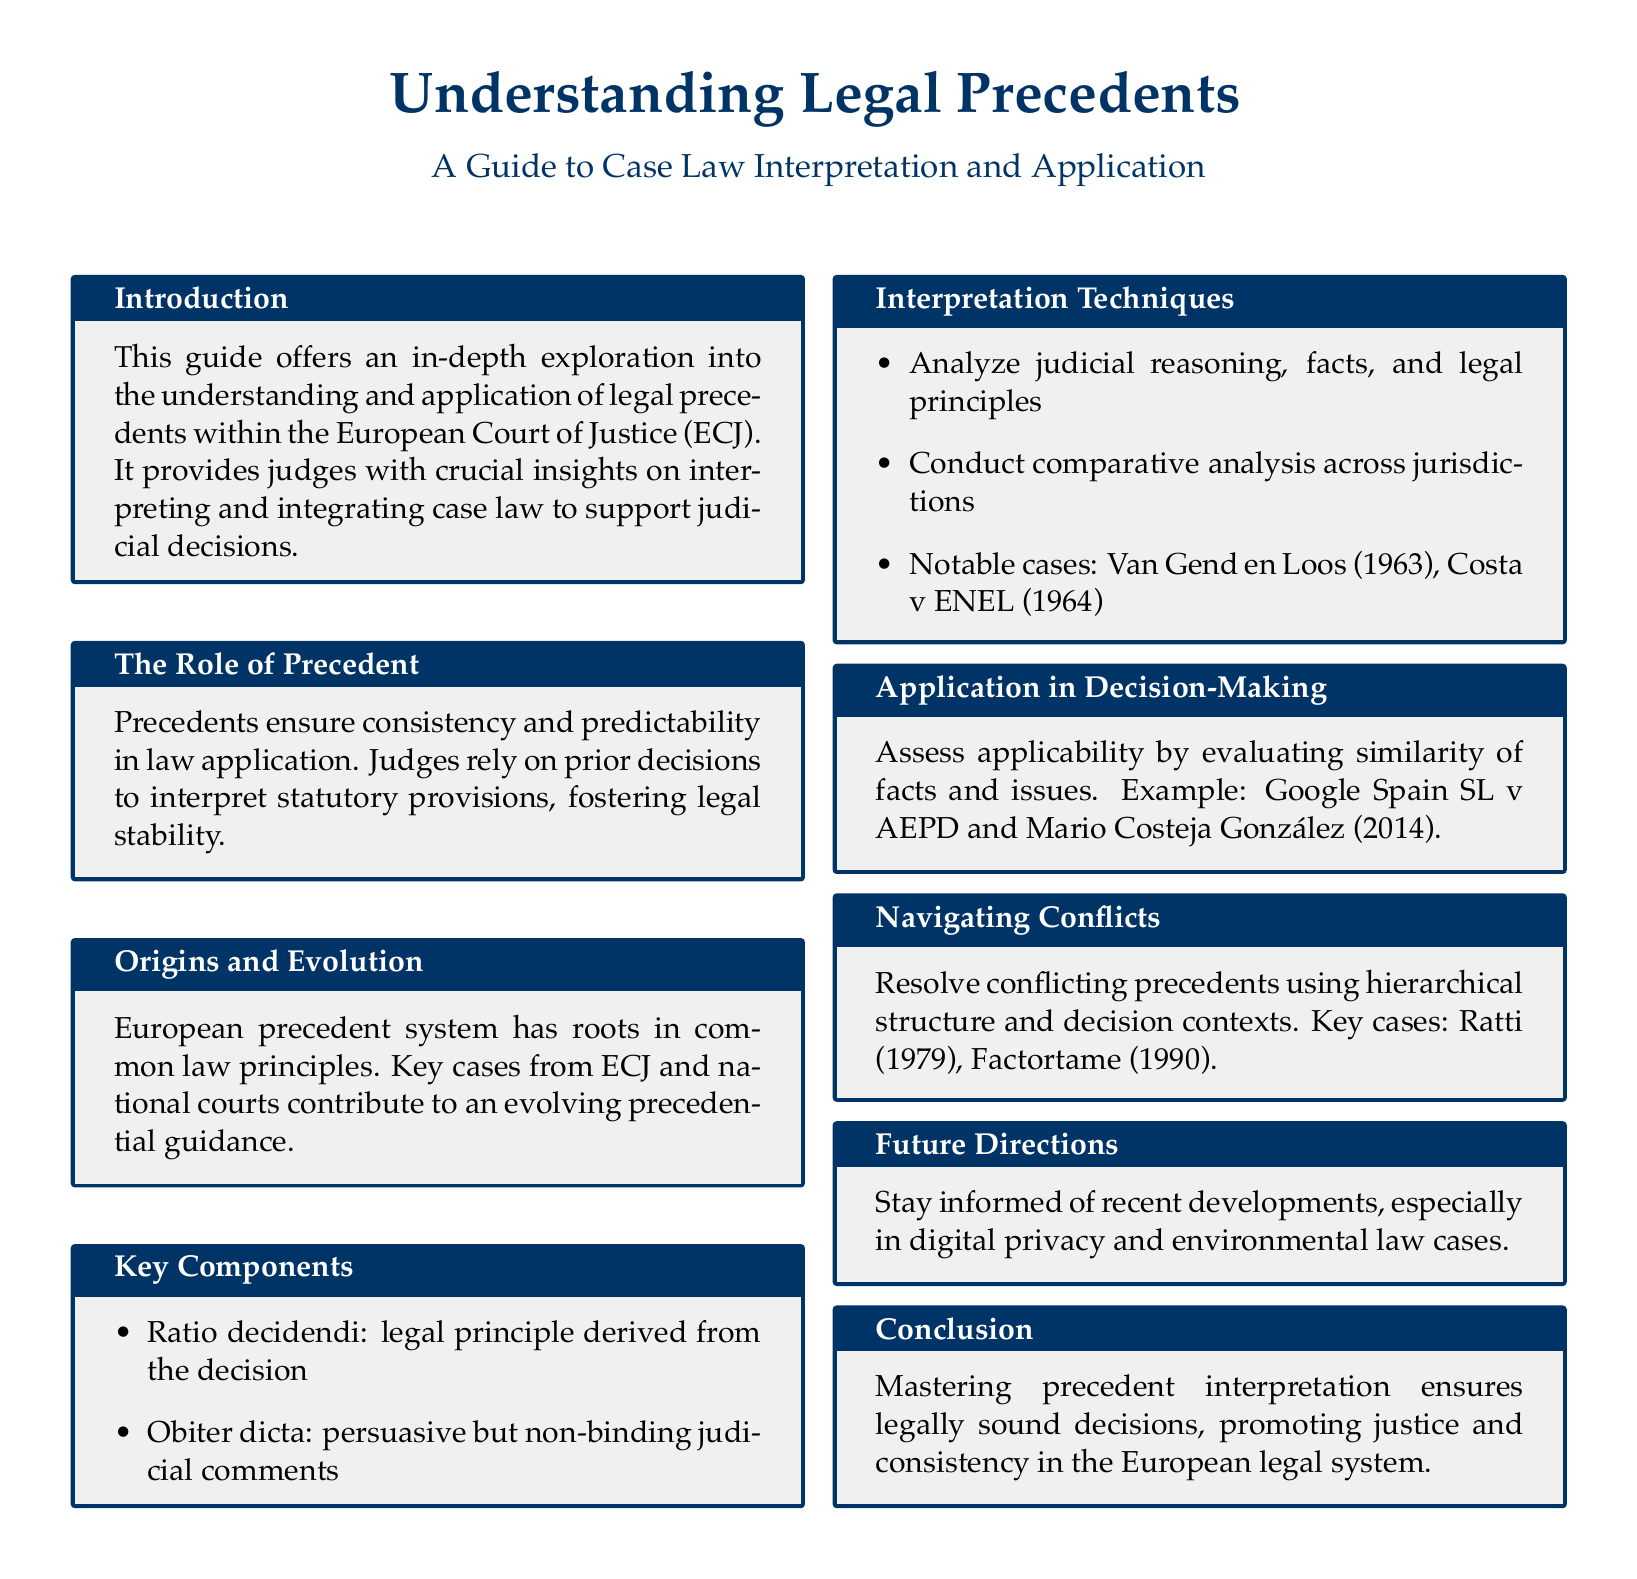What is the main purpose of this guide? The main purpose is to provide judges with crucial insights on interpreting and integrating case law to support judicial decisions.
Answer: To provide judges with crucial insights What is the term for the legal principle derived from a decision? The term for the legal principle derived from a decision is defined within key components of the document.
Answer: Ratio decidendi What are the notable cases mentioned in interpretation techniques? Notable cases are highlighted in the interpretation techniques section, examining their importance within precedential guidance.
Answer: Van Gend en Loos, Costa v ENEL Which year was the case Google Spain SL v AEPD decided? The document mentions the case Google Spain SL v AEPD and its relevance in the decision-making section, providing a specific year for reference.
Answer: 2014 What is the significance of obiter dicta? The document explains the role of obiter dicta within key components, clarifying its persuasive nature and non-binding status.
Answer: Persuasive but non-binding What should judges do when navigating conflicts between precedents? The document outlines steps judges should take when faced with conflicting precedents, ensuring a thorough understanding of resolution methods.
Answer: Use hierarchical structure and decision contexts What recent areas should judges stay informed about? The document advises on keeping abreast of recent developments in various fields to enhance judicial decision-making.
Answer: Digital privacy and environmental law What does mastering precedent interpretation promote? The document concludes by stating the broader implications of mastering precedent interpretation within the legal system.
Answer: Justice and consistency 